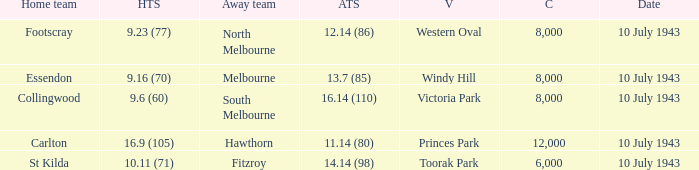When the Venue was victoria park, what was the Away team score? 16.14 (110). 